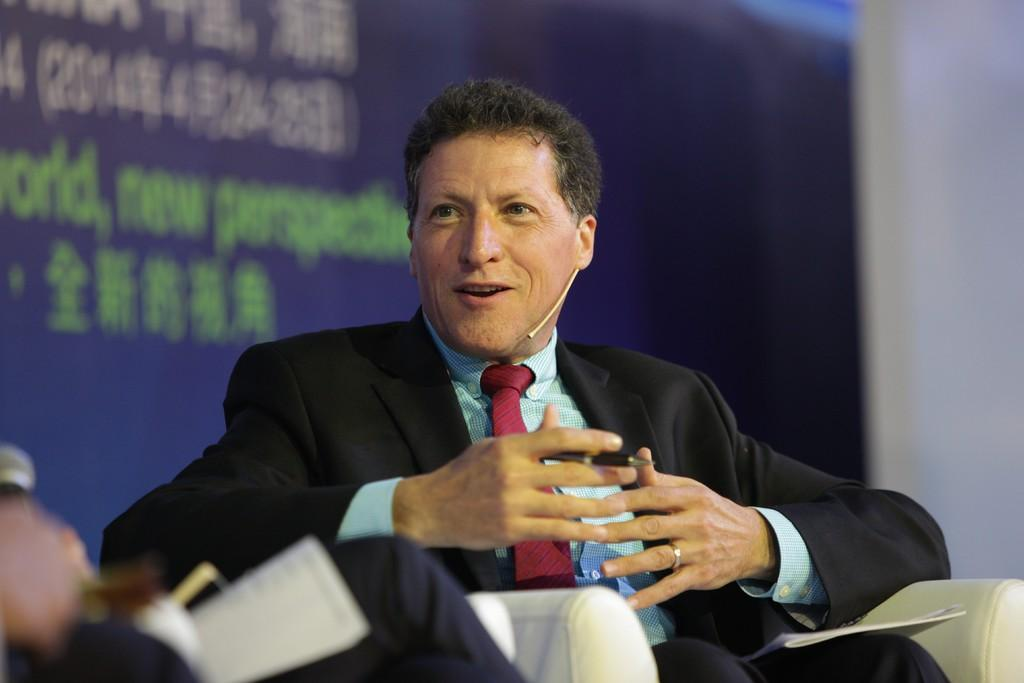What is the main subject of the image? There is a person in the image. What is the person doing in the image? The person is sitting on a chair and talking. What can be observed about the person's clothing in the image? The person is wearing a blue shirt, a red tie, and a black coat. What word is the person saying in the image? We cannot determine the specific word the person is saying in the image based on the provided facts. Is the person wearing a mask in the image? There is no mention of a mask in the image, so we cannot confirm or deny its presence. 